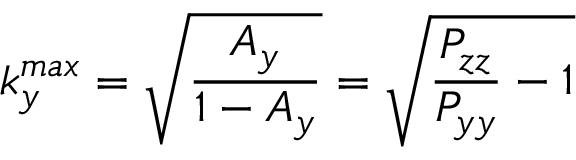Convert formula to latex. <formula><loc_0><loc_0><loc_500><loc_500>k _ { y } ^ { \max } = \sqrt { \frac { A _ { y } } { 1 - A _ { y } } } = \sqrt { \frac { P _ { z z } } { P _ { y y } } - 1 }</formula> 